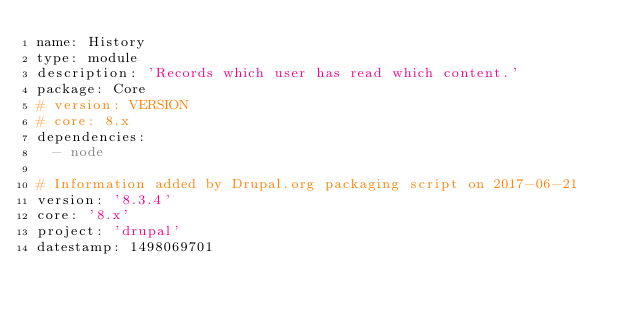Convert code to text. <code><loc_0><loc_0><loc_500><loc_500><_YAML_>name: History
type: module
description: 'Records which user has read which content.'
package: Core
# version: VERSION
# core: 8.x
dependencies:
  - node

# Information added by Drupal.org packaging script on 2017-06-21
version: '8.3.4'
core: '8.x'
project: 'drupal'
datestamp: 1498069701
</code> 